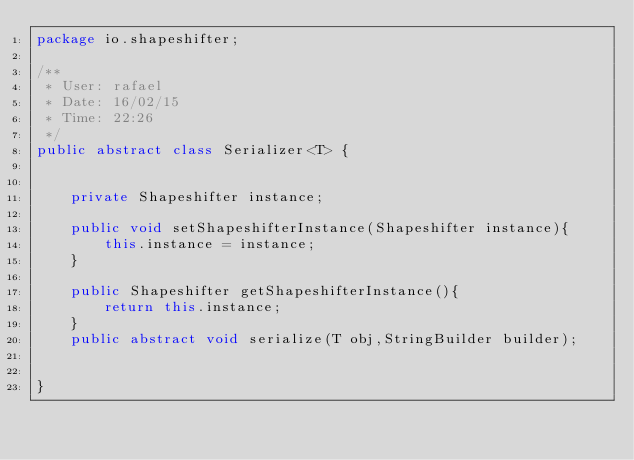<code> <loc_0><loc_0><loc_500><loc_500><_Java_>package io.shapeshifter;

/**
 * User: rafael
 * Date: 16/02/15
 * Time: 22:26
 */
public abstract class Serializer<T> {


    private Shapeshifter instance;

    public void setShapeshifterInstance(Shapeshifter instance){
        this.instance = instance;
    }

    public Shapeshifter getShapeshifterInstance(){
        return this.instance;
    }
    public abstract void serialize(T obj,StringBuilder builder);


}
</code> 